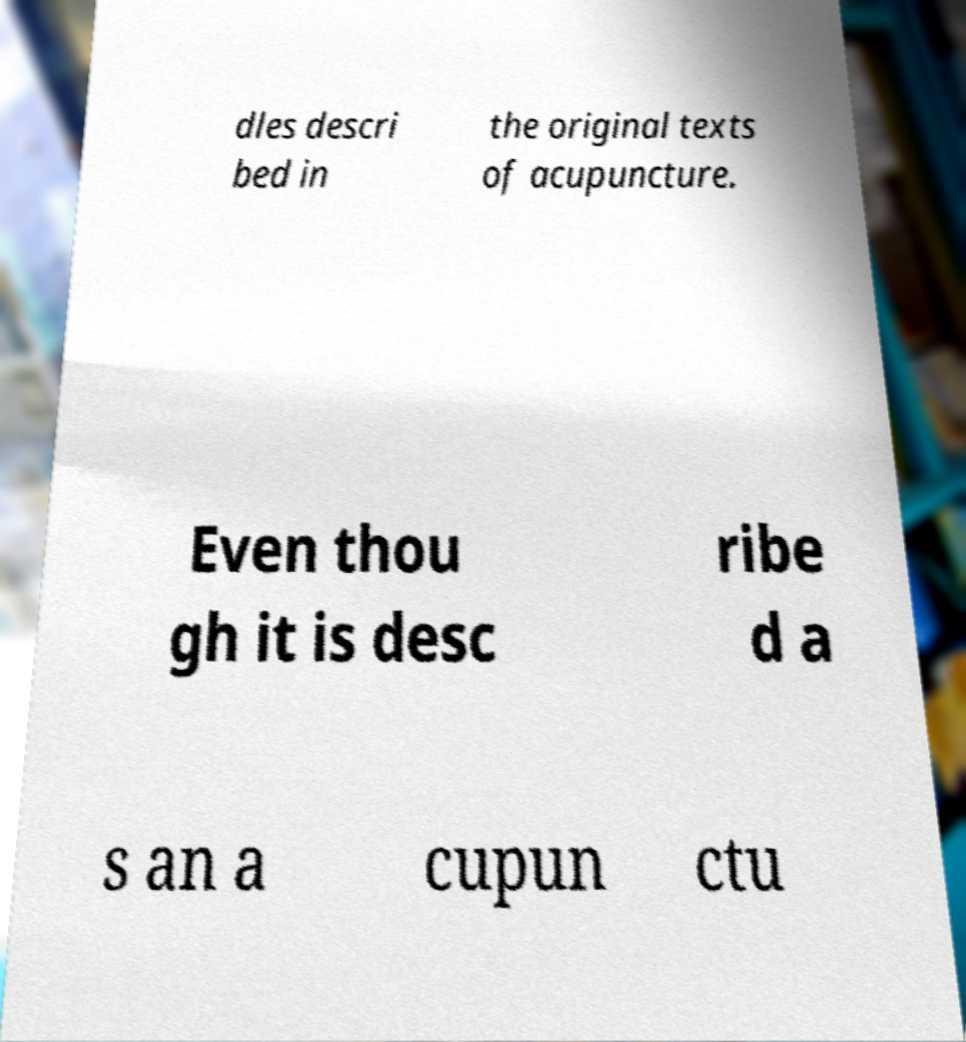Can you read and provide the text displayed in the image?This photo seems to have some interesting text. Can you extract and type it out for me? dles descri bed in the original texts of acupuncture. Even thou gh it is desc ribe d a s an a cupun ctu 